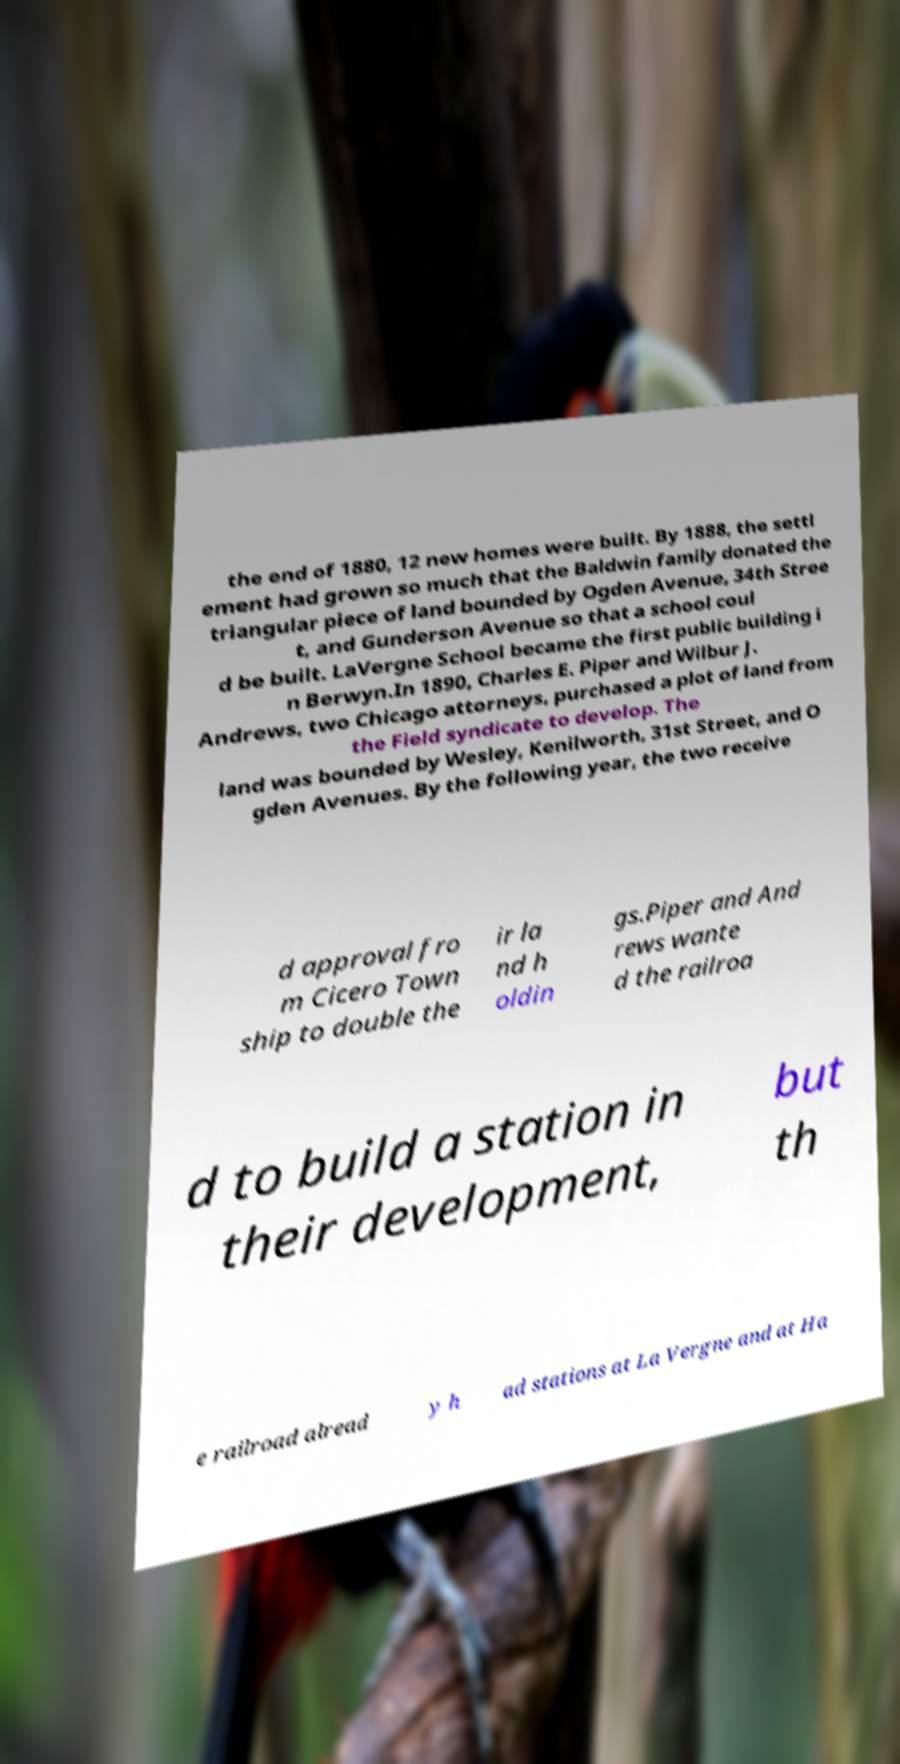There's text embedded in this image that I need extracted. Can you transcribe it verbatim? the end of 1880, 12 new homes were built. By 1888, the settl ement had grown so much that the Baldwin family donated the triangular piece of land bounded by Ogden Avenue, 34th Stree t, and Gunderson Avenue so that a school coul d be built. LaVergne School became the first public building i n Berwyn.In 1890, Charles E. Piper and Wilbur J. Andrews, two Chicago attorneys, purchased a plot of land from the Field syndicate to develop. The land was bounded by Wesley, Kenilworth, 31st Street, and O gden Avenues. By the following year, the two receive d approval fro m Cicero Town ship to double the ir la nd h oldin gs.Piper and And rews wante d the railroa d to build a station in their development, but th e railroad alread y h ad stations at La Vergne and at Ha 